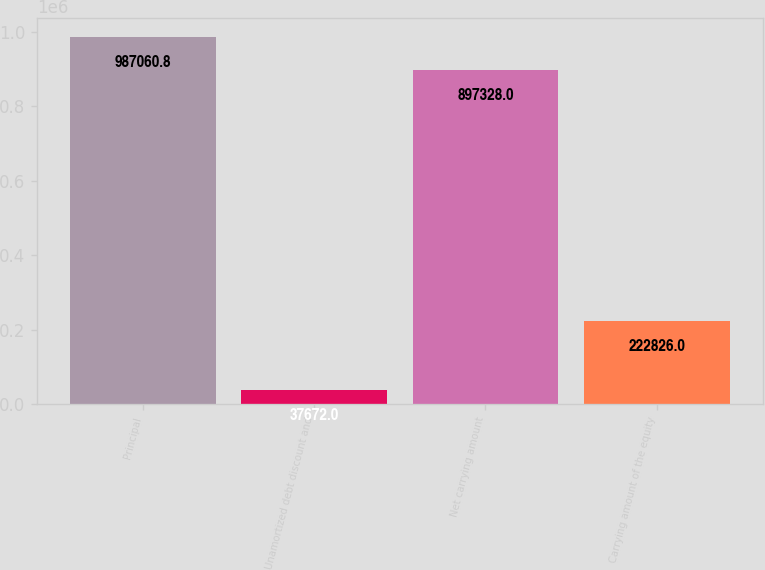Convert chart. <chart><loc_0><loc_0><loc_500><loc_500><bar_chart><fcel>Principal<fcel>Unamortized debt discount and<fcel>Net carrying amount<fcel>Carrying amount of the equity<nl><fcel>987061<fcel>37672<fcel>897328<fcel>222826<nl></chart> 